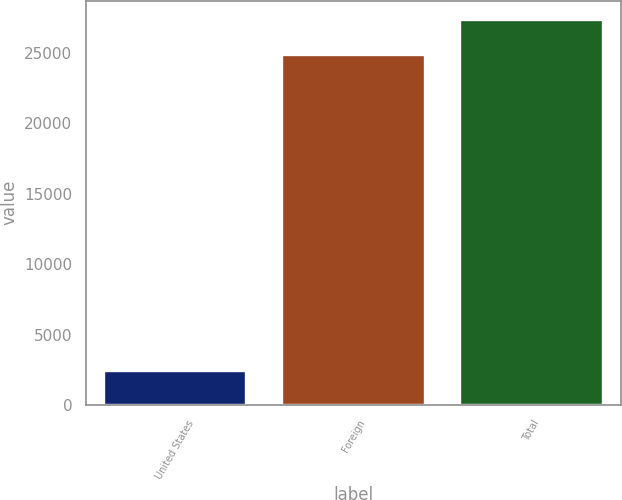<chart> <loc_0><loc_0><loc_500><loc_500><bar_chart><fcel>United States<fcel>Foreign<fcel>Total<nl><fcel>2439<fcel>24866<fcel>27352.6<nl></chart> 